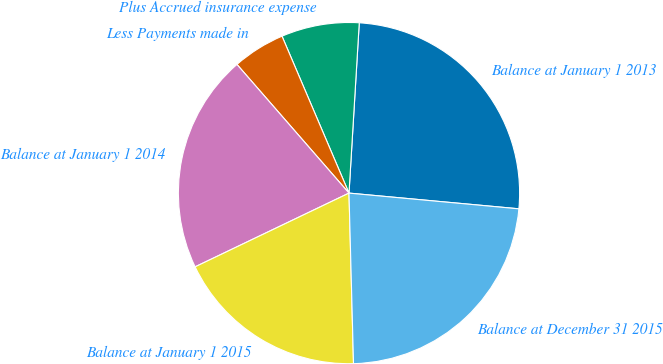Convert chart. <chart><loc_0><loc_0><loc_500><loc_500><pie_chart><fcel>Balance at January 1 2013<fcel>Plus Accrued insurance expense<fcel>Less Payments made in<fcel>Balance at January 1 2014<fcel>Balance at January 1 2015<fcel>Balance at December 31 2015<nl><fcel>25.51%<fcel>7.38%<fcel>4.98%<fcel>20.71%<fcel>18.31%<fcel>23.11%<nl></chart> 